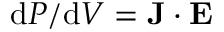Convert formula to latex. <formula><loc_0><loc_0><loc_500><loc_500>d P / d V = J \cdot E</formula> 